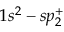Convert formula to latex. <formula><loc_0><loc_0><loc_500><loc_500>1 s ^ { 2 } - s p _ { 2 } ^ { + }</formula> 